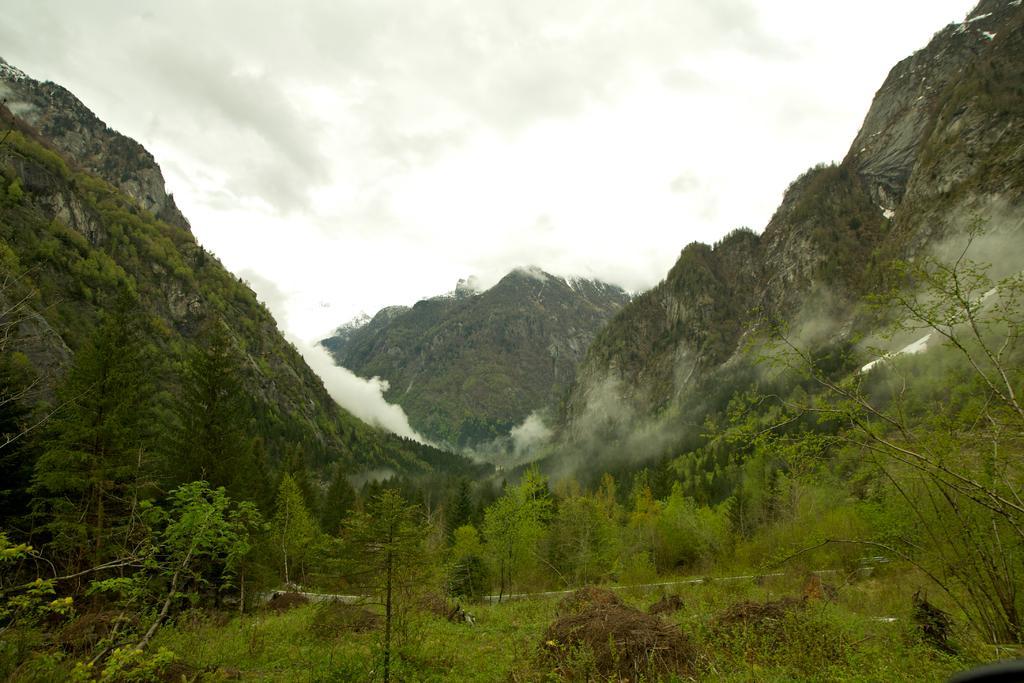How would you summarize this image in a sentence or two? At the bottom of this image, there are plants, trees and grass on the ground. In the background, there are mountains, smoke and there are clouds in the sky. 